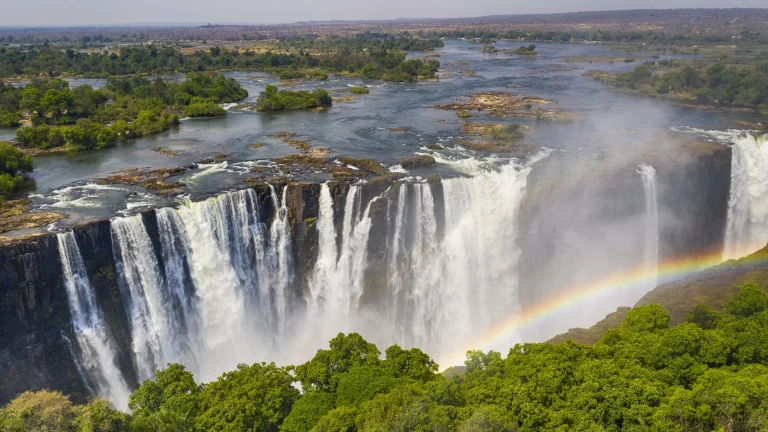Describe a day in the life of a bird living near this waterfall. A day in the life of a bird living near Victoria Falls begins at dawn, as the first rays of sunlight cut through the misty air. The bird, perhaps a colorful kingfisher or a majestic eagle, awakens to the thunderous roar of the falls, a sound as constant as the breath of the earth itself. It stretches its wings, catching the lightest of morning breezes, and takes flight, gliding effortlessly above the cascading torrents. As it soars, the bird hunts for breakfast, diving into the river to snatch a fish or two before retreating to a perch on a nearby tree, safe from the powerful spray. Midday is spent exploring the lush forests surrounding the falls, interacting with other birds and animals, and maybe even performing an aerial display to attract a mate. In the afternoon, it might rest on a high vantage point, watching the myriad of tourists below, eyeing the rainbows formed in the mist. As the sun sets, the bird returns to its nest, settling in for the night amidst the natural symphony of the African wilderness, the constant rumble of Victoria Falls like a lullaby. Describe the perspective of a fish living in the Zambezi River, just before it tumbles over the falls. For a fish living in the Zambezi River, the journey towards Victoria Falls is one of gradual change from serene to tumultuous. The river starts as a calm expanse where the fish navigates through clear, tranquil waters, searching for food among the aquatic vegetation. As it drifts downstream, the water begins to pick up speed, signaling a change in its environment. The fish senses the increasing current and murmur of distant thunder growing louder with each passing moment. The once gentle riverbed now gives way to rocky outcrops and the water turns from clear to churning and frothy. Just before the precipice, the fish experiences a mix of curiosity and instinctual fear, the surroundings transforming into a chaotic whirlpool. The roar of the falls now deafening, the fish fights to navigate the swirling waters, darting towards calmer eddies or the riverbank, instinctively knowing the peril that lies ahead. As it approaches the edge, it is swept into the powerful flow, engulfed in the tumult, and then, in a breathless moment, it is airborne, tumbling with the cascading torrent over the magnificent Victoria Falls. What role does the mist play in the ecosystem around Victoria Falls? The mist generated by Victoria Falls plays a crucial role in the local ecosystem, creating a unique microclimate that supports a diverse array of flora and fauna. This perpetual spray of water helps maintain lush, tropical vegetation in the immediate vicinity, providing moisture in an otherwise variable climate. The constant humidity nurtures a mini rainforest, home to species that thrive in these conditions, such as ferns, palms, and a variety of flowering plants. Additionally, the mist offers a water source for many animals, from insects to larger mammals, especially during dry seasons. It also helps to moderate local temperatures, reducing extreme heat on sunny days. This consistent availability of moisture supports a rich biodiversity, ensuring the area around the falls remains a vibrant and thriving habitat. Think creatively: If the mist from the falls were magical, what kinds of abilities might it grant to those it touches? Imagine if the mist from Victoria Falls held magical properties, bestowing extraordinary abilities upon those it touched. Anyone who walked through or was enveloped by this enchanted mist might gain the power to control water, able to manipulate rivers, lakes, and rains with a mere thought or gesture. Others might find themselves with the ability to communicate with animals, understanding the intricate languages of the birds, fish, and other creatures that inhabit the Zambezi's ecosystem. The mist could also grant enhanced senses, allowing individuals to see in the dark, hear the faintest whisper carried by the wind, or sense the heartbeat of the earth beneath them. Furthermore, it might offer healing properties, mending wounds and illnesses, both physical and emotional, restoring the body and spirit with its mystical energy. Perhaps it even imparts visions of the past or future, connecting those it touches with the ancient spirits of the land, revealing undiscovered secrets of nature and humanity. 